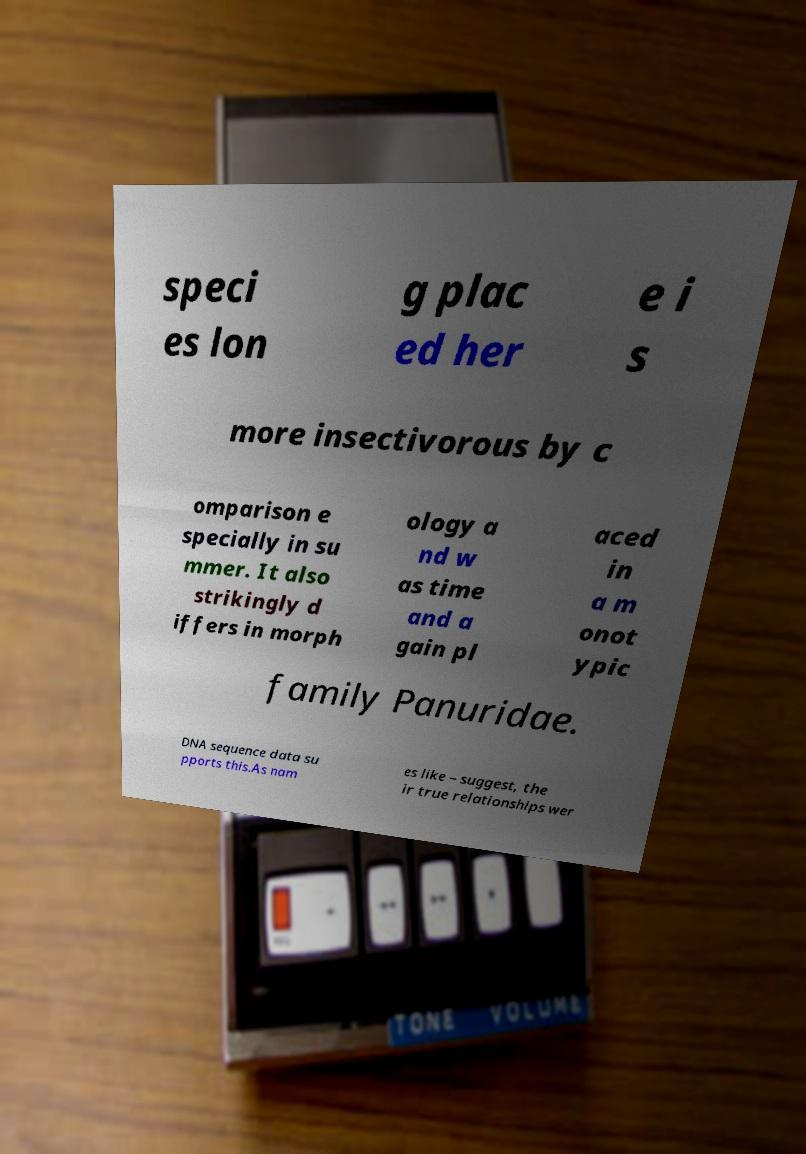What messages or text are displayed in this image? I need them in a readable, typed format. speci es lon g plac ed her e i s more insectivorous by c omparison e specially in su mmer. It also strikingly d iffers in morph ology a nd w as time and a gain pl aced in a m onot ypic family Panuridae. DNA sequence data su pports this.As nam es like – suggest, the ir true relationships wer 